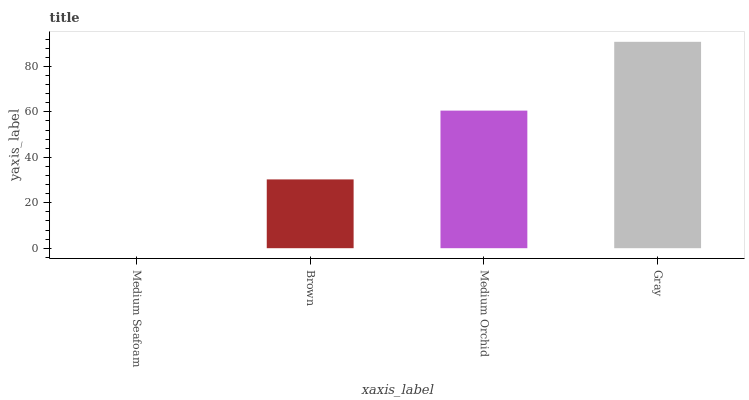Is Medium Seafoam the minimum?
Answer yes or no. Yes. Is Gray the maximum?
Answer yes or no. Yes. Is Brown the minimum?
Answer yes or no. No. Is Brown the maximum?
Answer yes or no. No. Is Brown greater than Medium Seafoam?
Answer yes or no. Yes. Is Medium Seafoam less than Brown?
Answer yes or no. Yes. Is Medium Seafoam greater than Brown?
Answer yes or no. No. Is Brown less than Medium Seafoam?
Answer yes or no. No. Is Medium Orchid the high median?
Answer yes or no. Yes. Is Brown the low median?
Answer yes or no. Yes. Is Gray the high median?
Answer yes or no. No. Is Medium Orchid the low median?
Answer yes or no. No. 